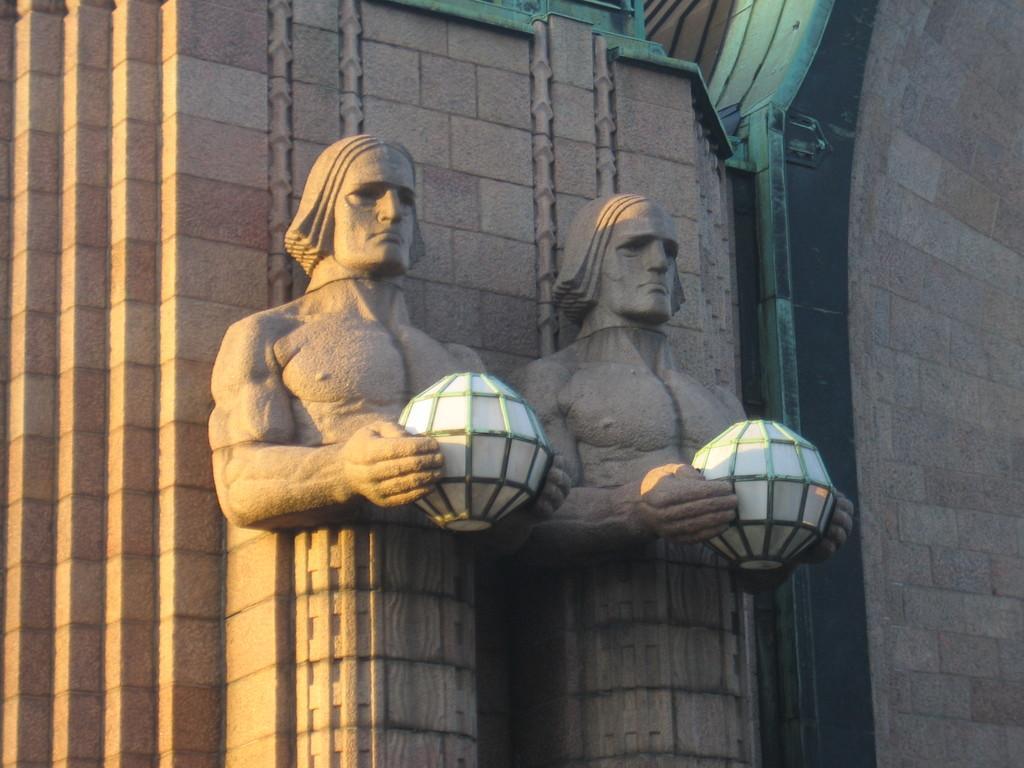Describe this image in one or two sentences. In this image I can see two status holding some object. Background the wall is in brown color. 